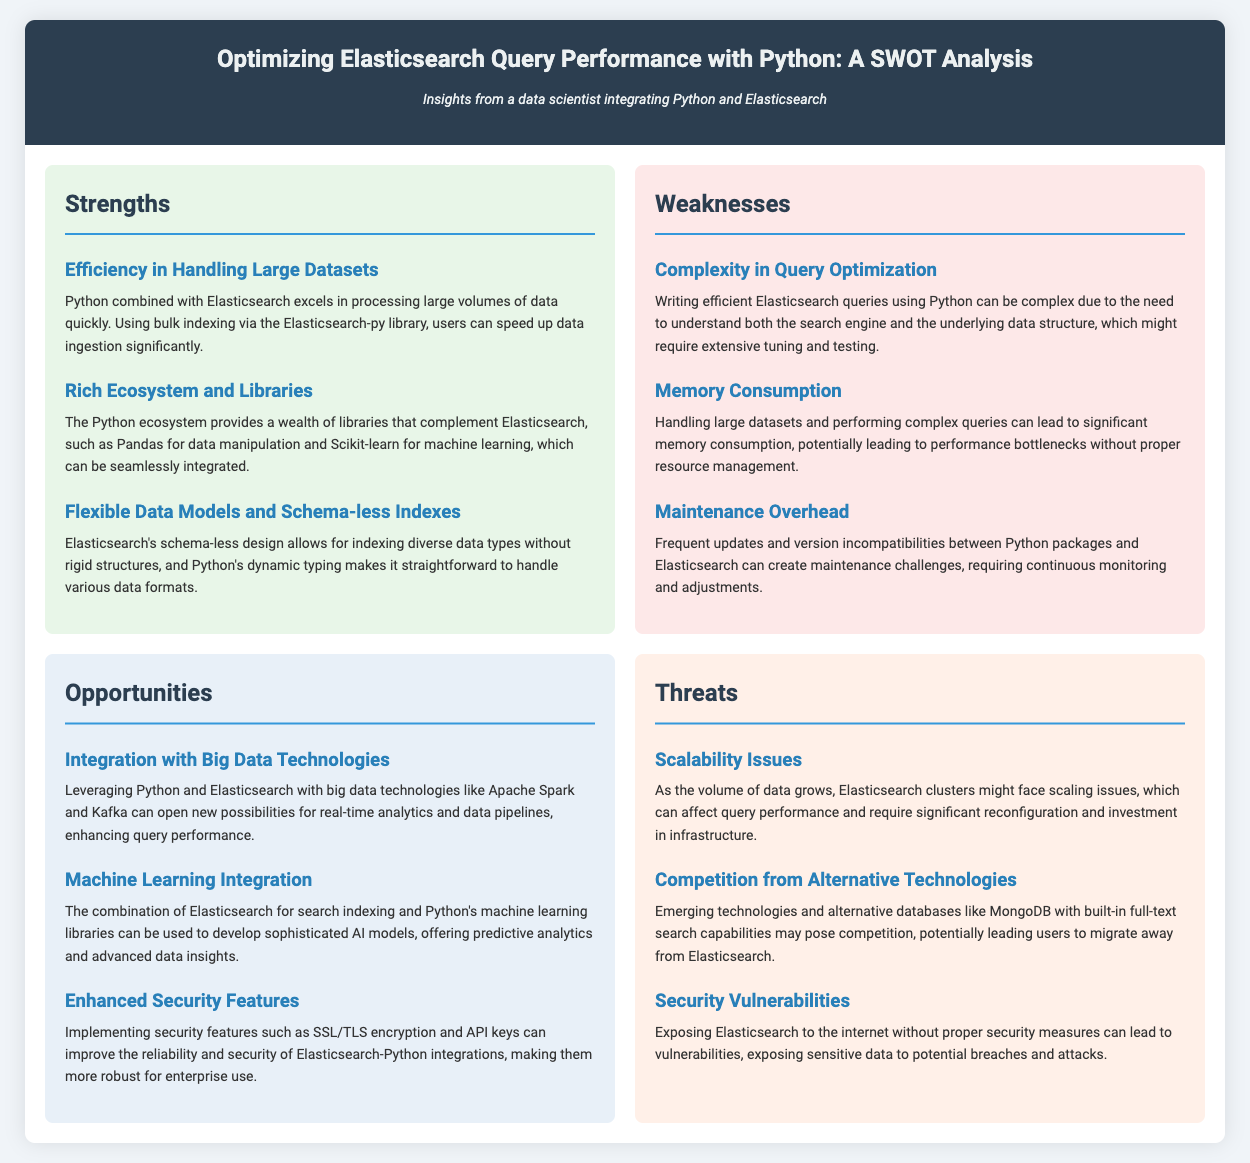What is the title of the document? The title is displayed prominently at the top of the document, summarizing the main topic.
Answer: Optimizing Elasticsearch Query Performance with Python: SWOT Analysis How many strengths are listed in the document? The document has a specific section where strengths are enumerated, providing clarity on the count.
Answer: 3 What is one opportunity mentioned in the SWOT analysis? Opportunities are highlighted and presented individually within their section, providing insights into potential advancements.
Answer: Integration with Big Data Technologies What challenge is associated with complex queries in Elasticsearch? The weaknesses section outlines specific challenges faced when dealing with Elasticsearch queries, requiring a deeper understanding.
Answer: Complexity in Query Optimization What is a threat mentioned related to security? Threats are identified concerning the security of Elasticsearch installations, detailing potential risks.
Answer: Security Vulnerabilities Which library in Python can be used for data manipulation alongside Elasticsearch? The strengths section mentions specific Python libraries that enhance the capabilities of Elasticsearch in data processing.
Answer: Pandas What could be a consequence of not managing memory effectively with large datasets? The document describes potential outcomes of poor resource management, emphasizing the impact on performance.
Answer: Performance bottlenecks What is a feature of Elasticsearch's data structure? The strengths section points out key characteristics of Elasticsearch's design that benefit users.
Answer: Schema-less design How does Python's dynamic typing benefit Elasticsearch users? The strengths section explains how Python's design can aid in the handling of various data formats efficiently.
Answer: Straightforward handling of various data formats 